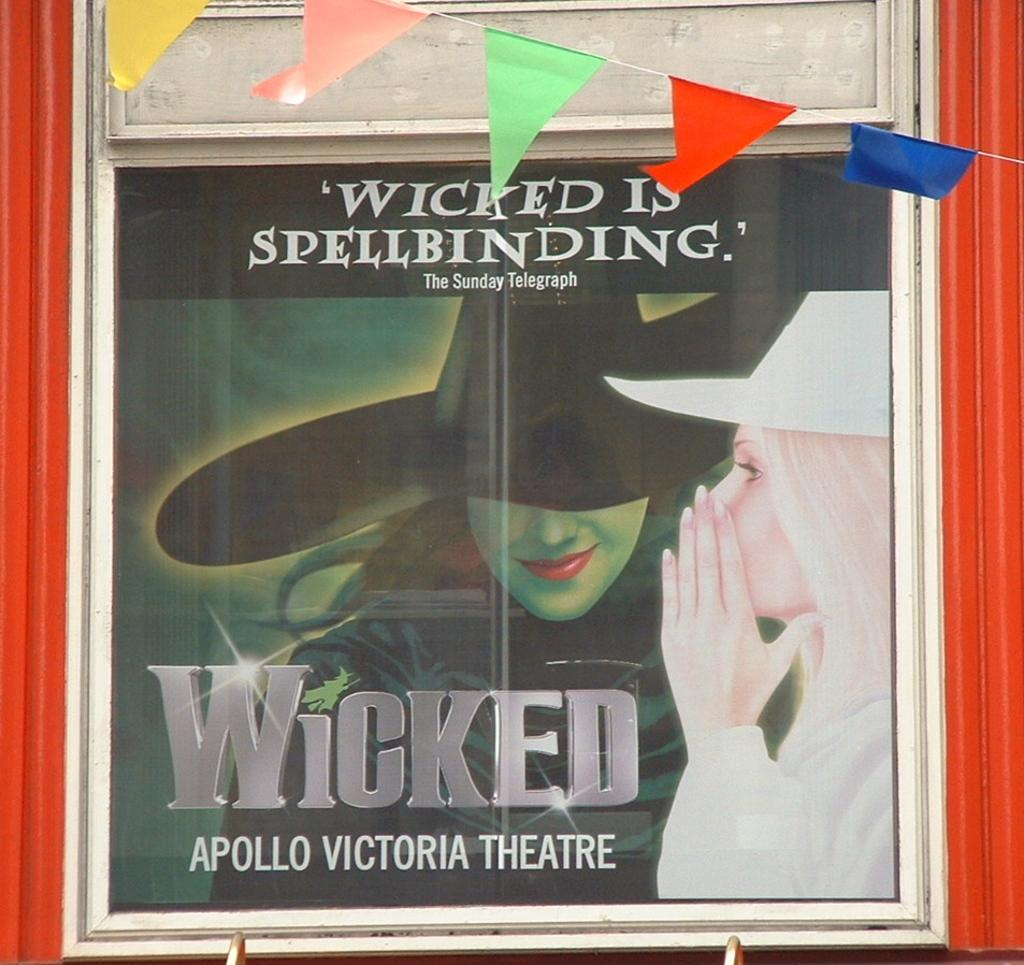<image>
Relay a brief, clear account of the picture shown. A cover for the Sunday Telegraph depicts a good witch and a wicked witch. 